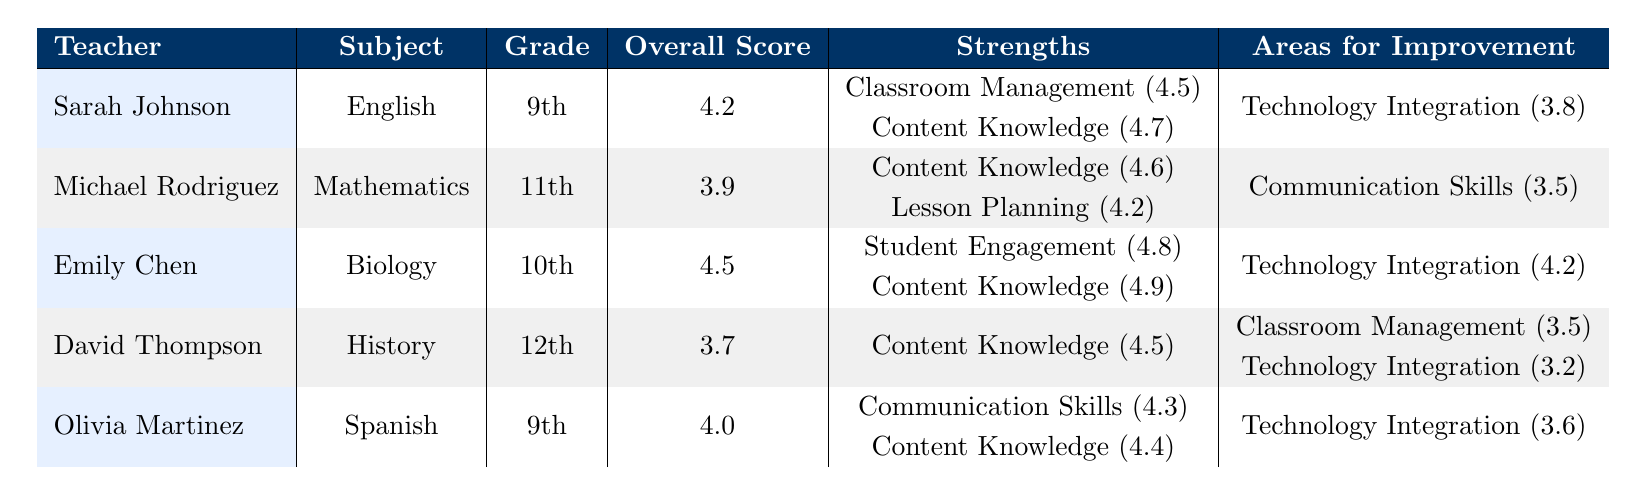What is the overall score of Emily Chen? The table lists the overall scores for each teacher. For Emily Chen, the overall score is specified directly as 4.5 in her row.
Answer: 4.5 Which teacher has the highest score in classroom management? The table shows classroom management scores for each teacher. Sarah Johnson has the highest score at 4.5, while others have lower scores.
Answer: Sarah Johnson What areas does Michael Rodriguez need to improve in? The table indicates the areas for improvement for each teacher. For Michael Rodriguez, the area needing improvement is communication skills, rated at 3.5.
Answer: Communication skills Calculate the average overall score of all teachers listed. The overall scores are 4.2, 3.9, 4.5, 3.7, and 4.0. Summing these gives 20.3, and dividing by the number of teachers (5) gives an average score of 4.06.
Answer: 4.06 What is the difference between the highest and lowest student engagement scores? The highest student engagement score is 4.8 (Emily Chen) and the lowest is 3.6 (David Thompson). The difference is calculated as 4.8 - 3.6 = 1.2.
Answer: 1.2 Is Olivia Martinez’s technology integration score higher than David Thompson’s? According to the table, Olivia Martinez has a technology integration score of 3.6 and David Thompson has 3.2. Since 3.6 is greater than 3.2, the answer is yes.
Answer: Yes Which teacher received the most professional development hours? The professional development hours for each teacher are listed: Sarah Johnson (25), Michael Rodriguez (18), Emily Chen (32), David Thompson (15), Olivia Martinez (22). Emily Chen has the highest at 32 hours.
Answer: Emily Chen How many teachers scored above 4.0 on their overall score? The teachers with an overall score above 4.0 are Sarah Johnson (4.2), Emily Chen (4.5), and Olivia Martinez (4.0). Counting these, there are 3 teachers.
Answer: 3 What feedback did the principal give to David Thompson? The table contains specific principal feedback for each teacher. For David Thompson, it states “Excellent content knowledge. Focus on improving classroom management and student engagement.”
Answer: Excellent content knowledge; focus on improving classroom management and student engagement Which teacher has the lowest peer observation score, and what is it? The peer observation scores provided are: Sarah Johnson (4.3), Michael Rodriguez (4.0), Emily Chen (4.6), David Thompson (3.8), and Olivia Martinez (4.1). David Thompson has the lowest score at 3.8.
Answer: David Thompson; 3.8 